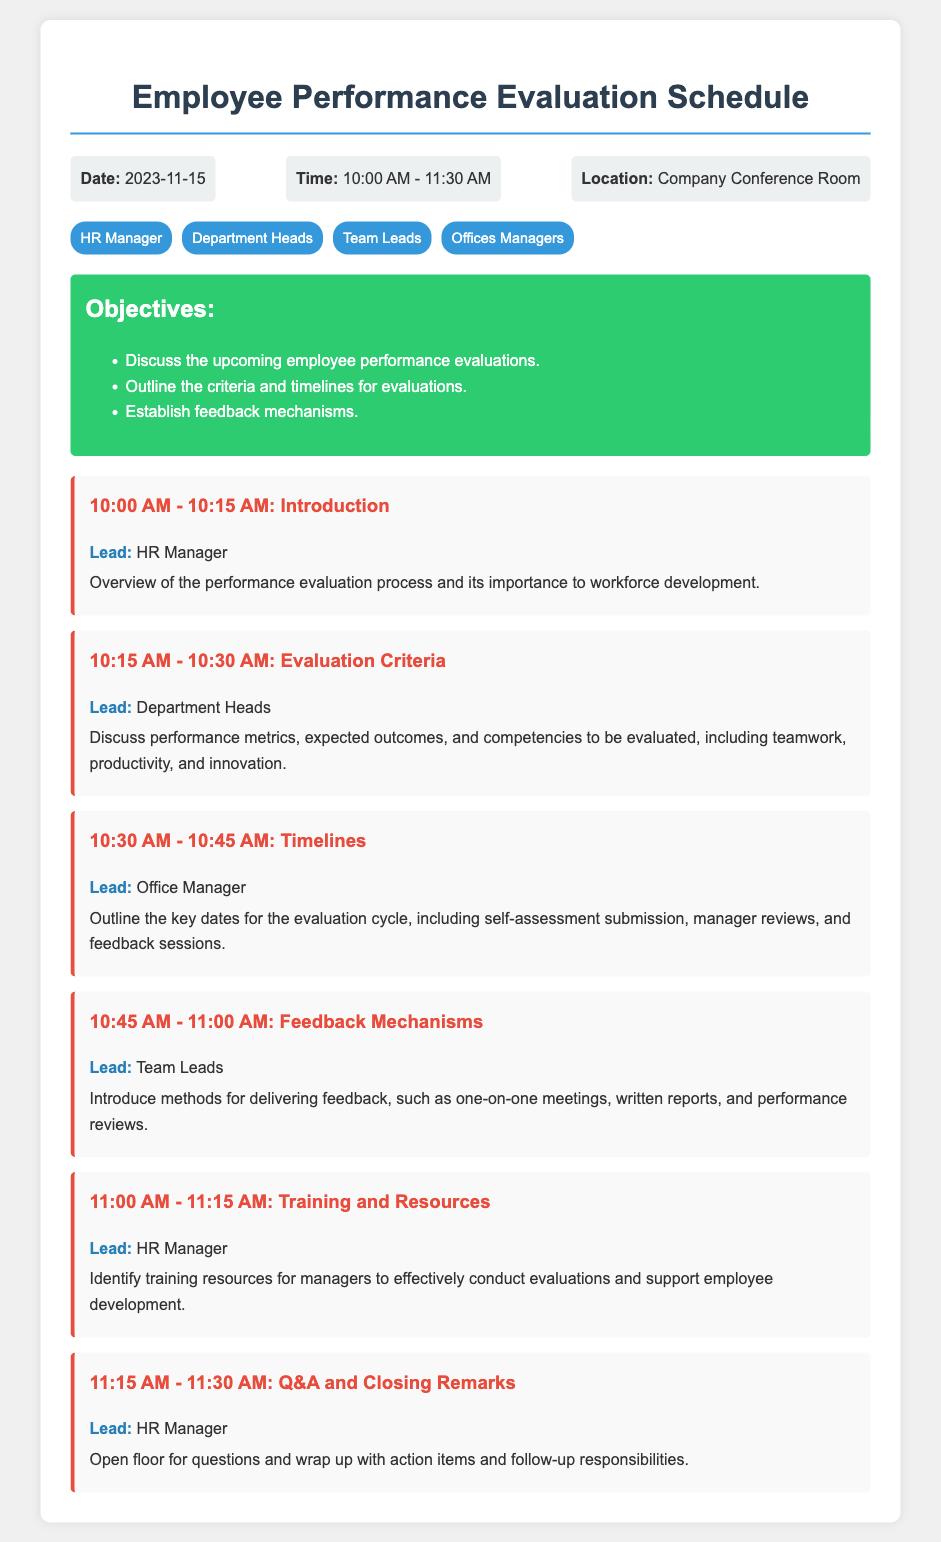What is the date of the performance evaluation meeting? The date of the meeting is explicitly stated in the header of the document.
Answer: 2023-11-15 What time does the meeting start? The start time is mentioned in the header information section of the document.
Answer: 10:00 AM Who is leading the introduction session? The lead for the introduction session is specified in the schedule section of the document.
Answer: HR Manager What is the duration of the feedback mechanisms session? The duration can be calculated based on the time slots provided in the schedule section.
Answer: 15 minutes What are the participants of the meeting? The participants are listed in the participants section at the beginning of the document.
Answer: HR Manager, Department Heads, Team Leads, Offices Managers How many objectives are outlined for the meeting? The number of objectives can be counted from the objectives section of the document.
Answer: Three What is the last agenda item scheduled for the meeting? The last agenda item is mentioned in the schedule section of the document.
Answer: Q&A and Closing Remarks Who is responsible for discussing the evaluation criteria? The responsible party for this discussion is identified in the schedule section.
Answer: Department Heads What is the location of the meeting? The location is specified clearly in the header information of the document.
Answer: Company Conference Room 